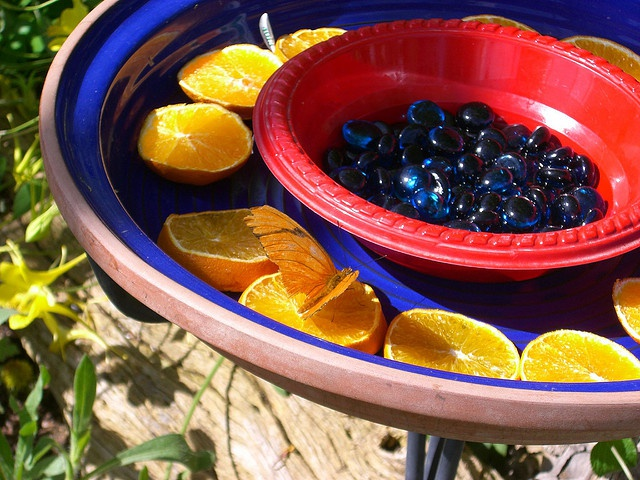Describe the objects in this image and their specific colors. I can see bowl in darkgreen, black, red, and maroon tones, bowl in darkgreen, lightpink, pink, gray, and brown tones, orange in darkgreen, olive, maroon, and red tones, orange in darkgreen, orange, and gold tones, and orange in darkgreen, orange, brown, and gold tones in this image. 